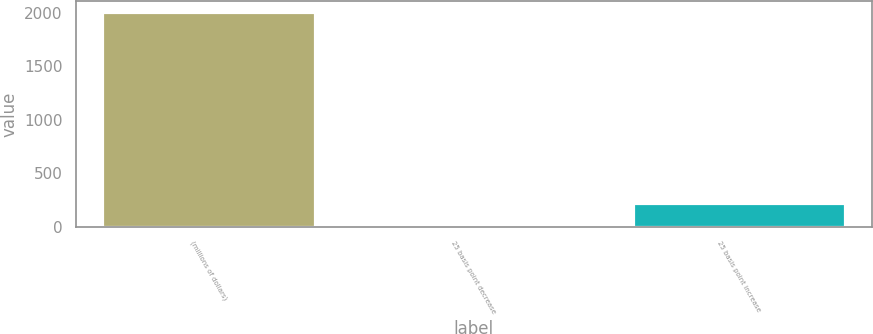Convert chart. <chart><loc_0><loc_0><loc_500><loc_500><bar_chart><fcel>(millions of dollars)<fcel>25 basis point decrease<fcel>25 basis point increase<nl><fcel>2011<fcel>17.8<fcel>217.12<nl></chart> 